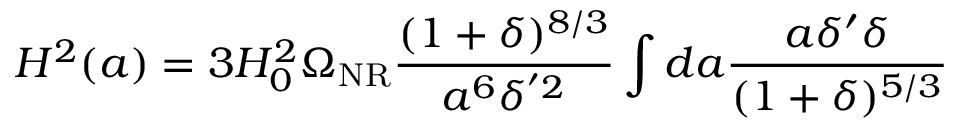Convert formula to latex. <formula><loc_0><loc_0><loc_500><loc_500>H ^ { 2 } ( a ) = 3 H _ { 0 } ^ { 2 } \Omega _ { N R } \frac { ( 1 + \delta ) ^ { 8 / 3 } } { a ^ { 6 } \delta ^ { ^ { \prime } 2 } } \int d a \frac { a \delta ^ { \prime } \delta } { ( 1 + \delta ) ^ { 5 / 3 } }</formula> 